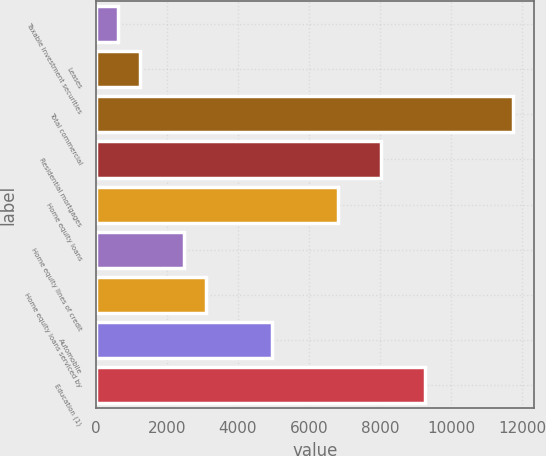Convert chart. <chart><loc_0><loc_0><loc_500><loc_500><bar_chart><fcel>Taxable investment securities<fcel>Leases<fcel>Total commercial<fcel>Residential mortgages<fcel>Home equity loans<fcel>Home equity lines of credit<fcel>Home equity loans serviced by<fcel>Automobile<fcel>Education (1)<nl><fcel>619.2<fcel>1237.4<fcel>11746.8<fcel>8037.6<fcel>6801.2<fcel>2473.8<fcel>3092<fcel>4946.6<fcel>9274<nl></chart> 